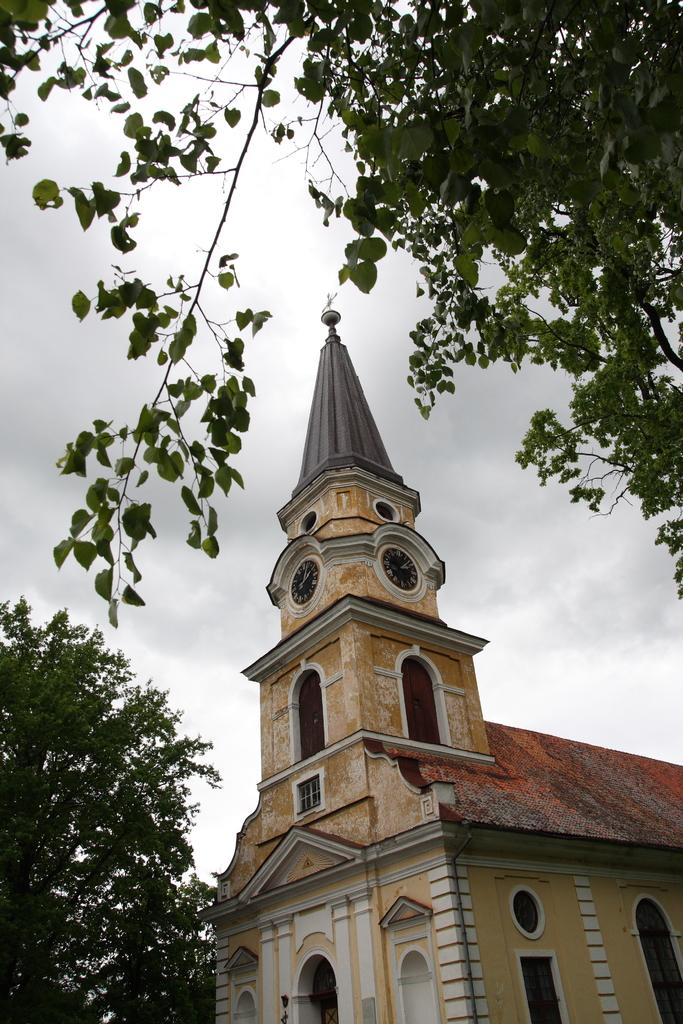What type of structure is present in the image? There is a building in the image. What feature can be seen on the building? The building has windows. Are there any specific details about the building? Yes, there are clocks on the building. What can be seen in the image besides the building? Trees are visible in the image. How would you describe the weather in the image? The sky is cloudy in the image. How many sisters are playing with bikes in the image? There are no sisters or bikes present in the image; it features a building with windows, clocks, trees, and a cloudy sky. 